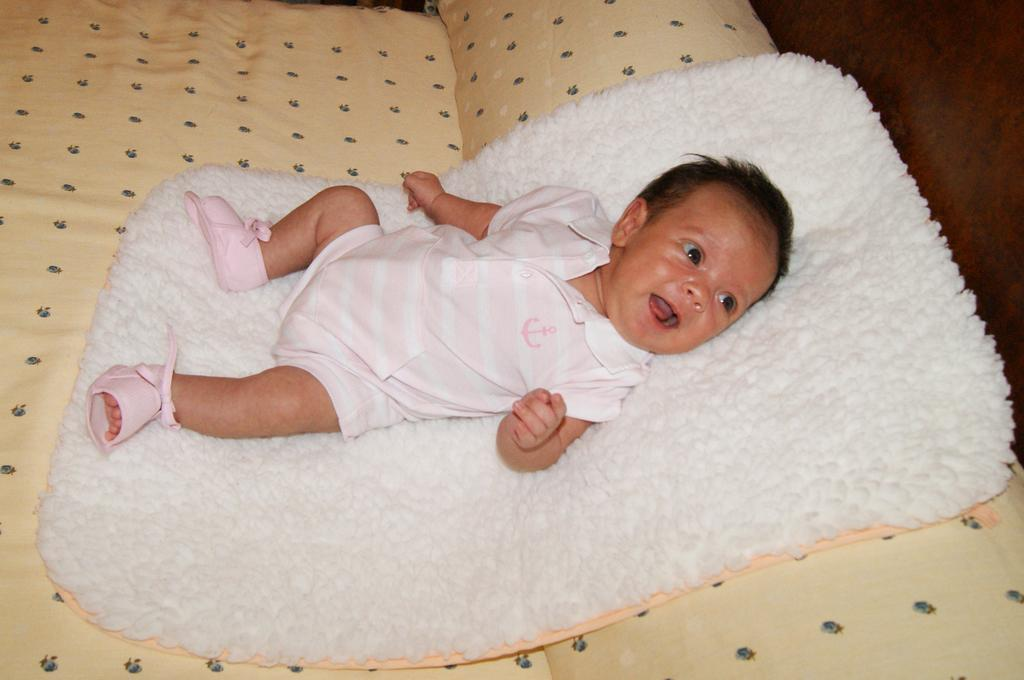What is the main subject of the image? The main subject of the image is an infant. Where is the infant located in the image? The infant is lying on a bed in the image. What is beneath the infant on the bed? There is a cloth on the bed below the infant. What type of clothing or accessory is on the infant's legs? The infant has footwear on their legs. What type of bulb is hanging above the infant in the image? There is no bulb present in the image; it only features an infant lying on a bed with a cloth beneath them and footwear on their legs. 